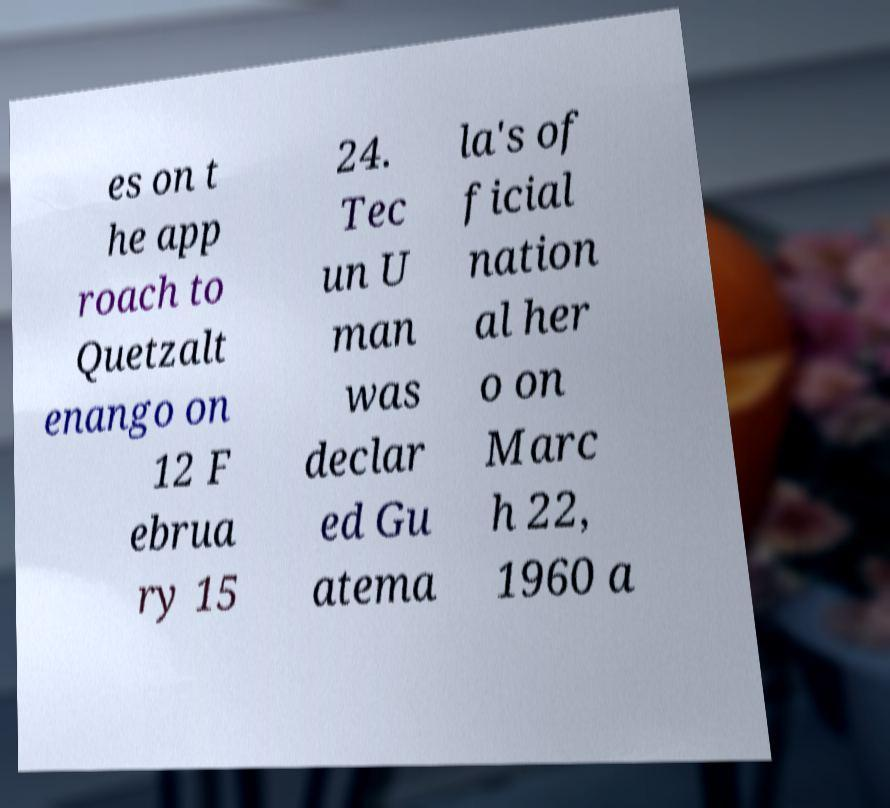Please read and relay the text visible in this image. What does it say? es on t he app roach to Quetzalt enango on 12 F ebrua ry 15 24. Tec un U man was declar ed Gu atema la's of ficial nation al her o on Marc h 22, 1960 a 